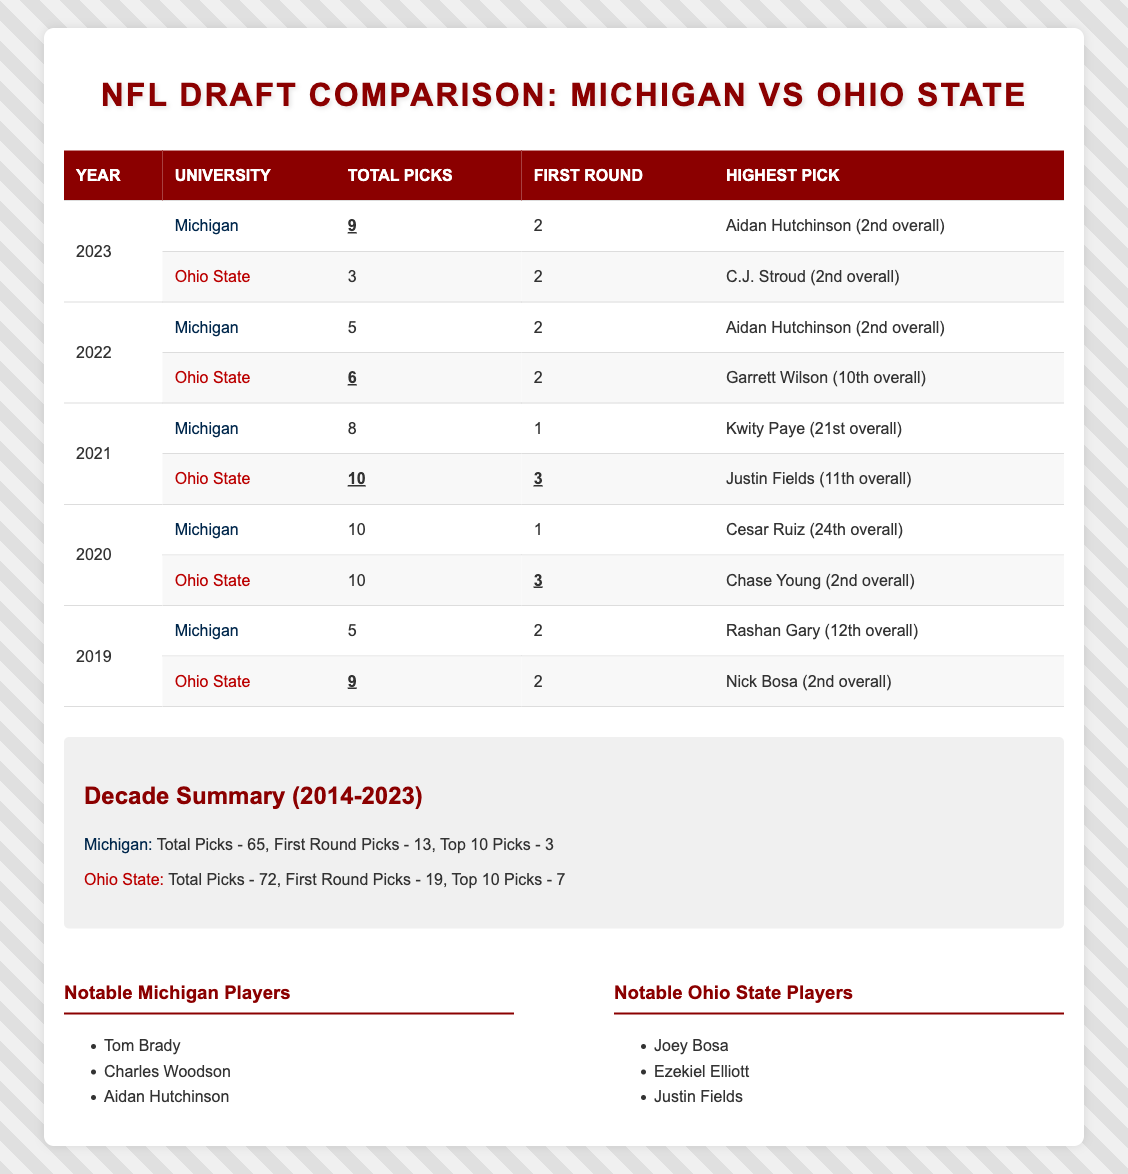What was the highest pick from Ohio State University in 2023? The table lists that Ohio State had 3 total picks in 2023, with the highest pick being C.J. Stroud (2nd overall).
Answer: C.J. Stroud (2nd overall) How many total draft picks did Michigan have in 2021? In the table, it shows that Michigan had 8 total picks in the year 2021.
Answer: 8 Which university had more first-round picks in the decade summary? The decade summary indicates that Ohio State had 19 first-round picks, while Michigan had 13. Since 19 is greater than 13, Ohio State had more first-round picks.
Answer: Ohio State What is the difference in total draft picks between Michigan and Ohio State in the last decade? From the decade summary, Michigan had 65 total picks and Ohio State had 72. To find the difference, we subtract: 72 - 65 = 7.
Answer: 7 Did Michigan have a first-round pick in 2020? The table shows that Michigan had 1 first-round pick in 2020, which means the answer to this fact-based question is yes.
Answer: Yes How many first-round picks did Ohio State have in 2022 compared to 2023? In the table, Ohio State had 2 first-round picks in 2022 and 2 first-round picks in 2023. Since these numbers are equal, there is no difference.
Answer: No difference In which year did Michigan have its highest total picks from the last decade? Reviewing the table, Michigan had its highest total picks in 2020 with 10 picks. First, we compare all total picks for each year, and 10 is the maximum number.
Answer: 2020 How many total players were drafted from Ohio State from 2019 to 2023? To find the total, we sum the total picks in the table for Ohio State from 2019 to 2023: 9 (2019) + 10 (2020) + 10 (2021) + 6 (2022) + 3 (2023) = 38.
Answer: 38 Which year had the highest overall pick from Michigan University? The highest pick listed for Michigan in the table was Aidan Hutchinson (2nd overall), which occurred in both 2022 and 2023. Both years had the same highest pick, therefore the answer includes these two years.
Answer: 2022 and 2023 